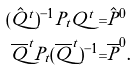<formula> <loc_0><loc_0><loc_500><loc_500>( \hat { Q } ^ { t } ) ^ { - 1 } P _ { t } Q ^ { t } = & \hat { P } ^ { 0 } \\ \overline { Q } ^ { t } P _ { t } ( \overline { Q } ^ { t } ) ^ { - 1 } = & \overline { P } ^ { 0 } .</formula> 